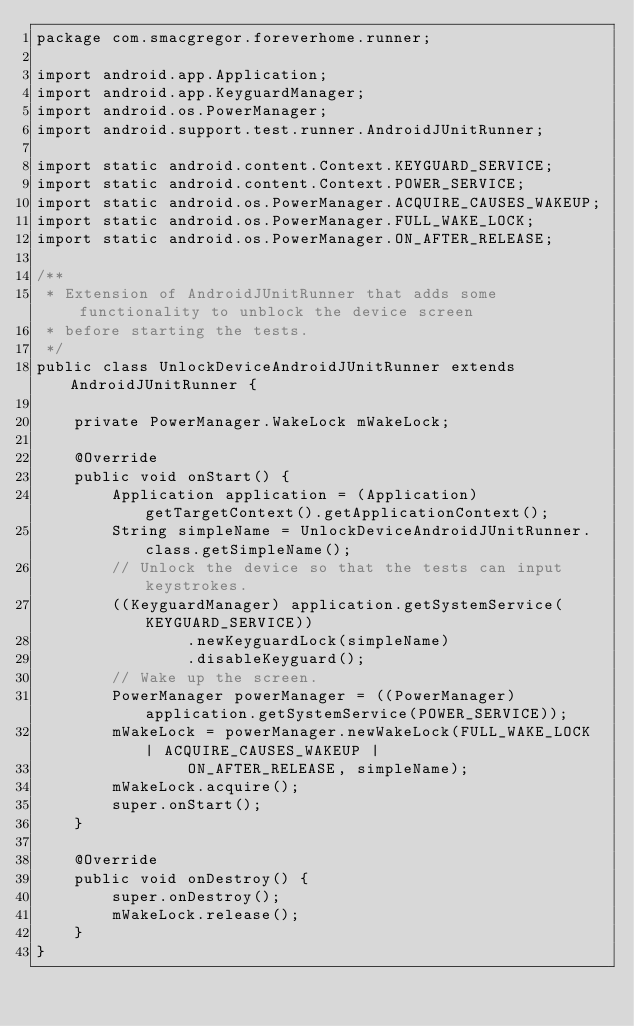Convert code to text. <code><loc_0><loc_0><loc_500><loc_500><_Java_>package com.smacgregor.foreverhome.runner;

import android.app.Application;
import android.app.KeyguardManager;
import android.os.PowerManager;
import android.support.test.runner.AndroidJUnitRunner;

import static android.content.Context.KEYGUARD_SERVICE;
import static android.content.Context.POWER_SERVICE;
import static android.os.PowerManager.ACQUIRE_CAUSES_WAKEUP;
import static android.os.PowerManager.FULL_WAKE_LOCK;
import static android.os.PowerManager.ON_AFTER_RELEASE;

/**
 * Extension of AndroidJUnitRunner that adds some functionality to unblock the device screen
 * before starting the tests.
 */
public class UnlockDeviceAndroidJUnitRunner extends AndroidJUnitRunner {

    private PowerManager.WakeLock mWakeLock;

    @Override
    public void onStart() {
        Application application = (Application) getTargetContext().getApplicationContext();
        String simpleName = UnlockDeviceAndroidJUnitRunner.class.getSimpleName();
        // Unlock the device so that the tests can input keystrokes.
        ((KeyguardManager) application.getSystemService(KEYGUARD_SERVICE))
                .newKeyguardLock(simpleName)
                .disableKeyguard();
        // Wake up the screen.
        PowerManager powerManager = ((PowerManager) application.getSystemService(POWER_SERVICE));
        mWakeLock = powerManager.newWakeLock(FULL_WAKE_LOCK | ACQUIRE_CAUSES_WAKEUP |
                ON_AFTER_RELEASE, simpleName);
        mWakeLock.acquire();
        super.onStart();
    }

    @Override
    public void onDestroy() {
        super.onDestroy();
        mWakeLock.release();
    }
}
</code> 